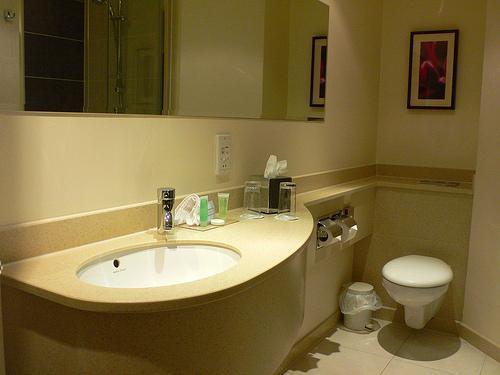How many glasses are on the sink?
Give a very brief answer. 2. 